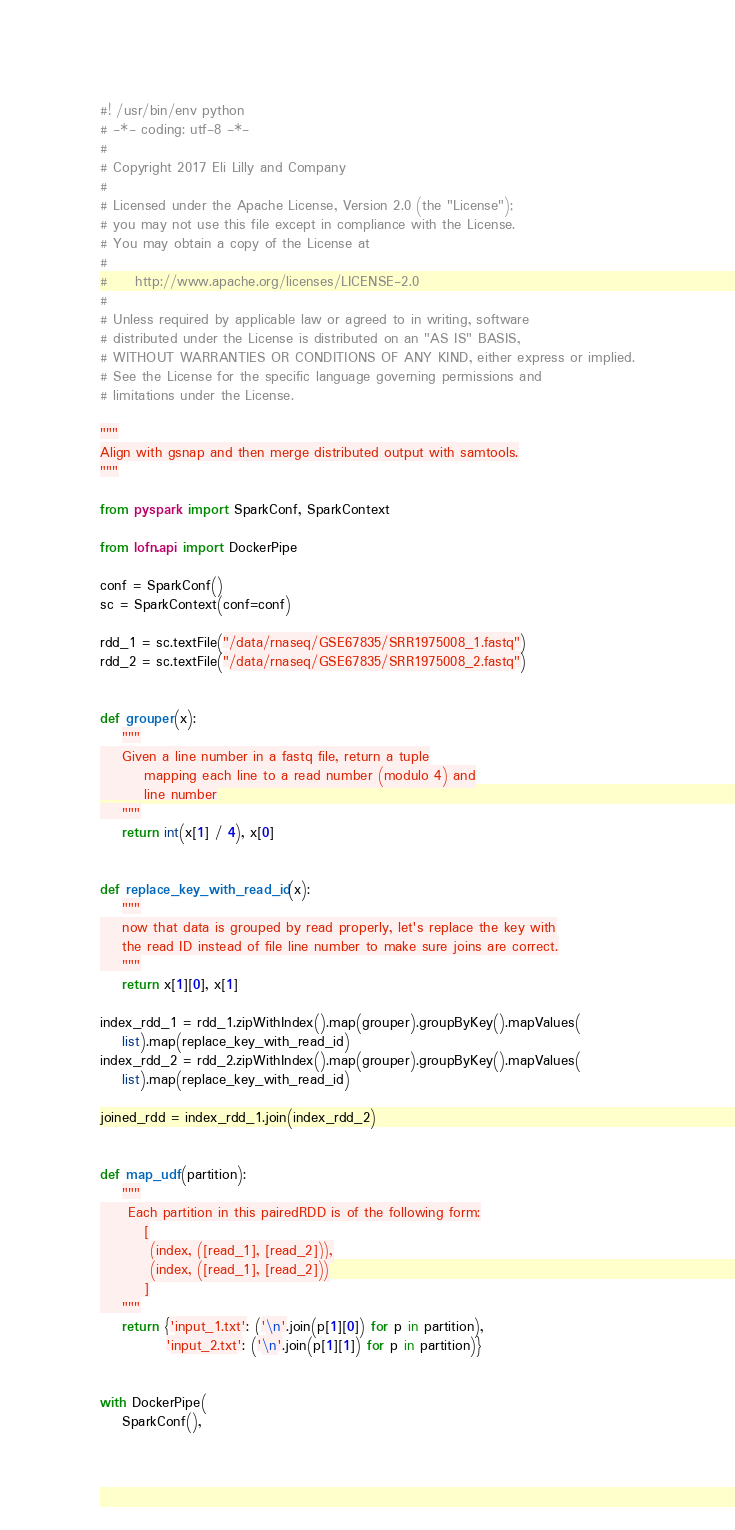Convert code to text. <code><loc_0><loc_0><loc_500><loc_500><_Python_>#! /usr/bin/env python
# -*- coding: utf-8 -*-
#
# Copyright 2017 Eli Lilly and Company
#
# Licensed under the Apache License, Version 2.0 (the "License");
# you may not use this file except in compliance with the License.
# You may obtain a copy of the License at
#
#     http://www.apache.org/licenses/LICENSE-2.0
#
# Unless required by applicable law or agreed to in writing, software
# distributed under the License is distributed on an "AS IS" BASIS,
# WITHOUT WARRANTIES OR CONDITIONS OF ANY KIND, either express or implied.
# See the License for the specific language governing permissions and
# limitations under the License.

"""
Align with gsnap and then merge distributed output with samtools.
"""

from pyspark import SparkConf, SparkContext

from lofn.api import DockerPipe

conf = SparkConf()
sc = SparkContext(conf=conf)

rdd_1 = sc.textFile("/data/rnaseq/GSE67835/SRR1975008_1.fastq")
rdd_2 = sc.textFile("/data/rnaseq/GSE67835/SRR1975008_2.fastq")


def grouper(x):
    """
    Given a line number in a fastq file, return a tuple
        mapping each line to a read number (modulo 4) and
        line number
    """
    return int(x[1] / 4), x[0]


def replace_key_with_read_id(x):
    """
    now that data is grouped by read properly, let's replace the key with
    the read ID instead of file line number to make sure joins are correct.
    """
    return x[1][0], x[1]

index_rdd_1 = rdd_1.zipWithIndex().map(grouper).groupByKey().mapValues(
    list).map(replace_key_with_read_id)
index_rdd_2 = rdd_2.zipWithIndex().map(grouper).groupByKey().mapValues(
    list).map(replace_key_with_read_id)

joined_rdd = index_rdd_1.join(index_rdd_2)


def map_udf(partition):
    """
     Each partition in this pairedRDD is of the following form:
        [
         (index, ([read_1], [read_2])),
         (index, ([read_1], [read_2]))
        ]
    """
    return {'input_1.txt': ('\n'.join(p[1][0]) for p in partition),
            'input_2.txt': ('\n'.join(p[1][1]) for p in partition)}


with DockerPipe(
    SparkConf(),</code> 